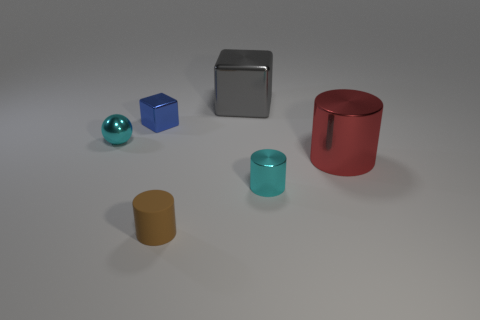Is there anything else that is made of the same material as the small brown thing?
Offer a terse response. No. What is the shape of the thing that is to the right of the rubber cylinder and behind the large red cylinder?
Offer a very short reply. Cube. There is a tiny thing that is the same shape as the big gray object; what color is it?
Keep it short and to the point. Blue. Are there any other things that have the same color as the tiny metallic cylinder?
Your response must be concise. Yes. The big metal object left of the large red thing that is in front of the object that is to the left of the blue object is what shape?
Your answer should be very brief. Cube. There is a cyan metal object that is right of the shiny sphere; does it have the same size as the cyan shiny object to the left of the blue object?
Offer a terse response. Yes. What number of small objects are the same material as the large gray object?
Provide a succinct answer. 3. There is a object that is in front of the tiny cyan object on the right side of the small blue object; what number of cyan shiny spheres are behind it?
Provide a short and direct response. 1. Does the blue metal object have the same shape as the gray shiny thing?
Provide a short and direct response. Yes. Are there any other shiny things of the same shape as the brown thing?
Give a very brief answer. Yes. 